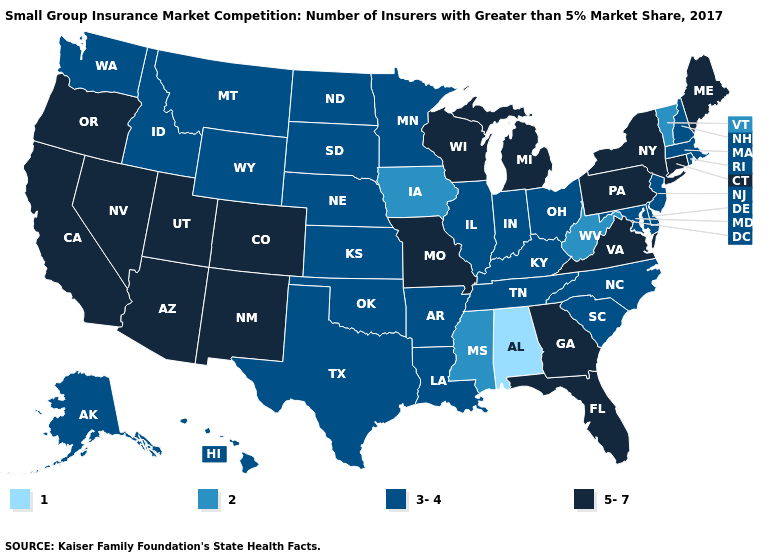Does Maryland have the highest value in the USA?
Give a very brief answer. No. Does Arizona have a lower value than New Jersey?
Short answer required. No. Name the states that have a value in the range 3-4?
Quick response, please. Alaska, Arkansas, Delaware, Hawaii, Idaho, Illinois, Indiana, Kansas, Kentucky, Louisiana, Maryland, Massachusetts, Minnesota, Montana, Nebraska, New Hampshire, New Jersey, North Carolina, North Dakota, Ohio, Oklahoma, Rhode Island, South Carolina, South Dakota, Tennessee, Texas, Washington, Wyoming. What is the highest value in states that border Washington?
Be succinct. 5-7. What is the lowest value in the MidWest?
Keep it brief. 2. Does Alabama have the highest value in the USA?
Write a very short answer. No. Name the states that have a value in the range 1?
Quick response, please. Alabama. Which states have the lowest value in the USA?
Short answer required. Alabama. Which states have the lowest value in the USA?
Answer briefly. Alabama. Among the states that border Minnesota , does Iowa have the lowest value?
Short answer required. Yes. Does the first symbol in the legend represent the smallest category?
Answer briefly. Yes. Does Kansas have a higher value than Iowa?
Keep it brief. Yes. What is the lowest value in the USA?
Quick response, please. 1. What is the highest value in the Northeast ?
Give a very brief answer. 5-7. What is the value of Kansas?
Concise answer only. 3-4. 